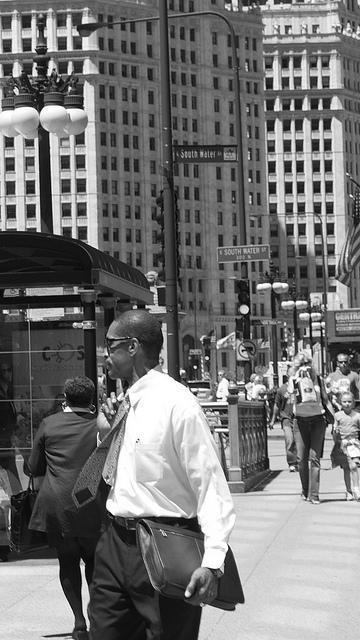How many people are there?
Give a very brief answer. 3. How many sentient beings are dogs in this image?
Give a very brief answer. 0. 